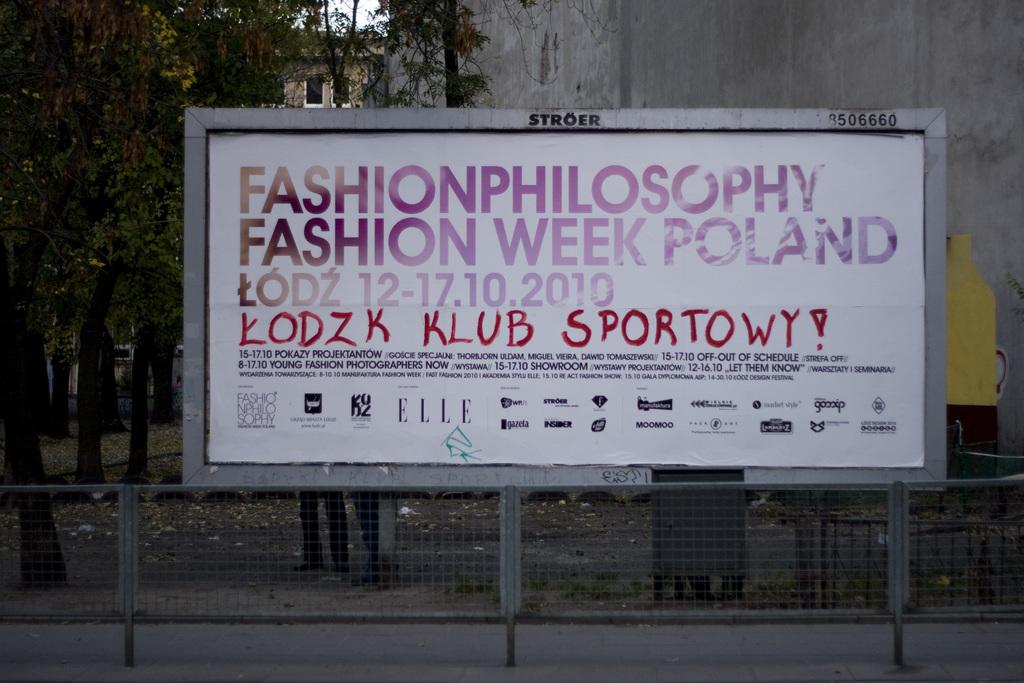Where is fashion week?
Offer a very short reply. Poland. What company owns the billboard?
Give a very brief answer. Stroer. 